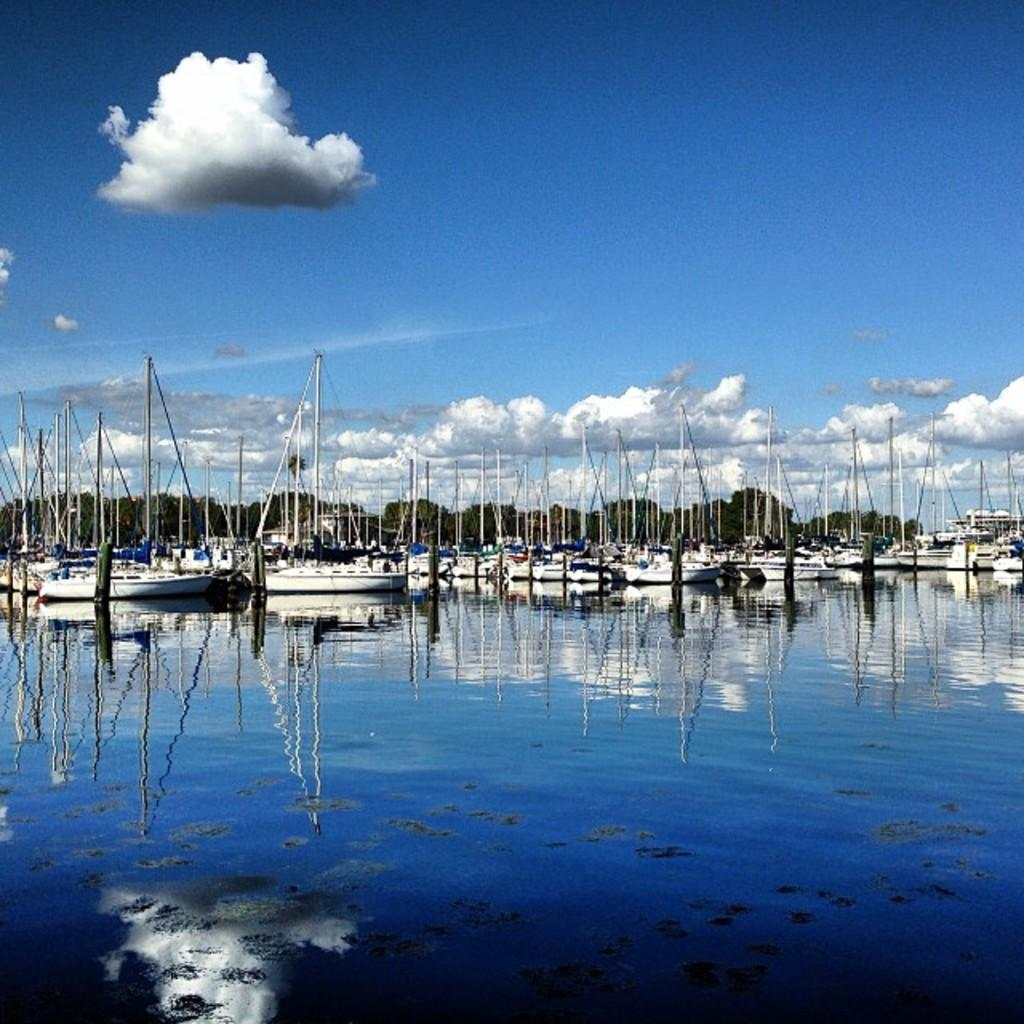What is at the bottom of the image? There is water at the bottom of the image. What is floating on the water? There are boats with poles on the water. What can be seen in the background of the image? There are trees in the background of the image. What is visible at the top of the image? The sky is visible at the top of the image. Can you see a stranger holding a fork in the image? There is no stranger or fork present in the image. Is there an airplane flying in the sky in the image? There is no airplane visible in the sky in the image. 